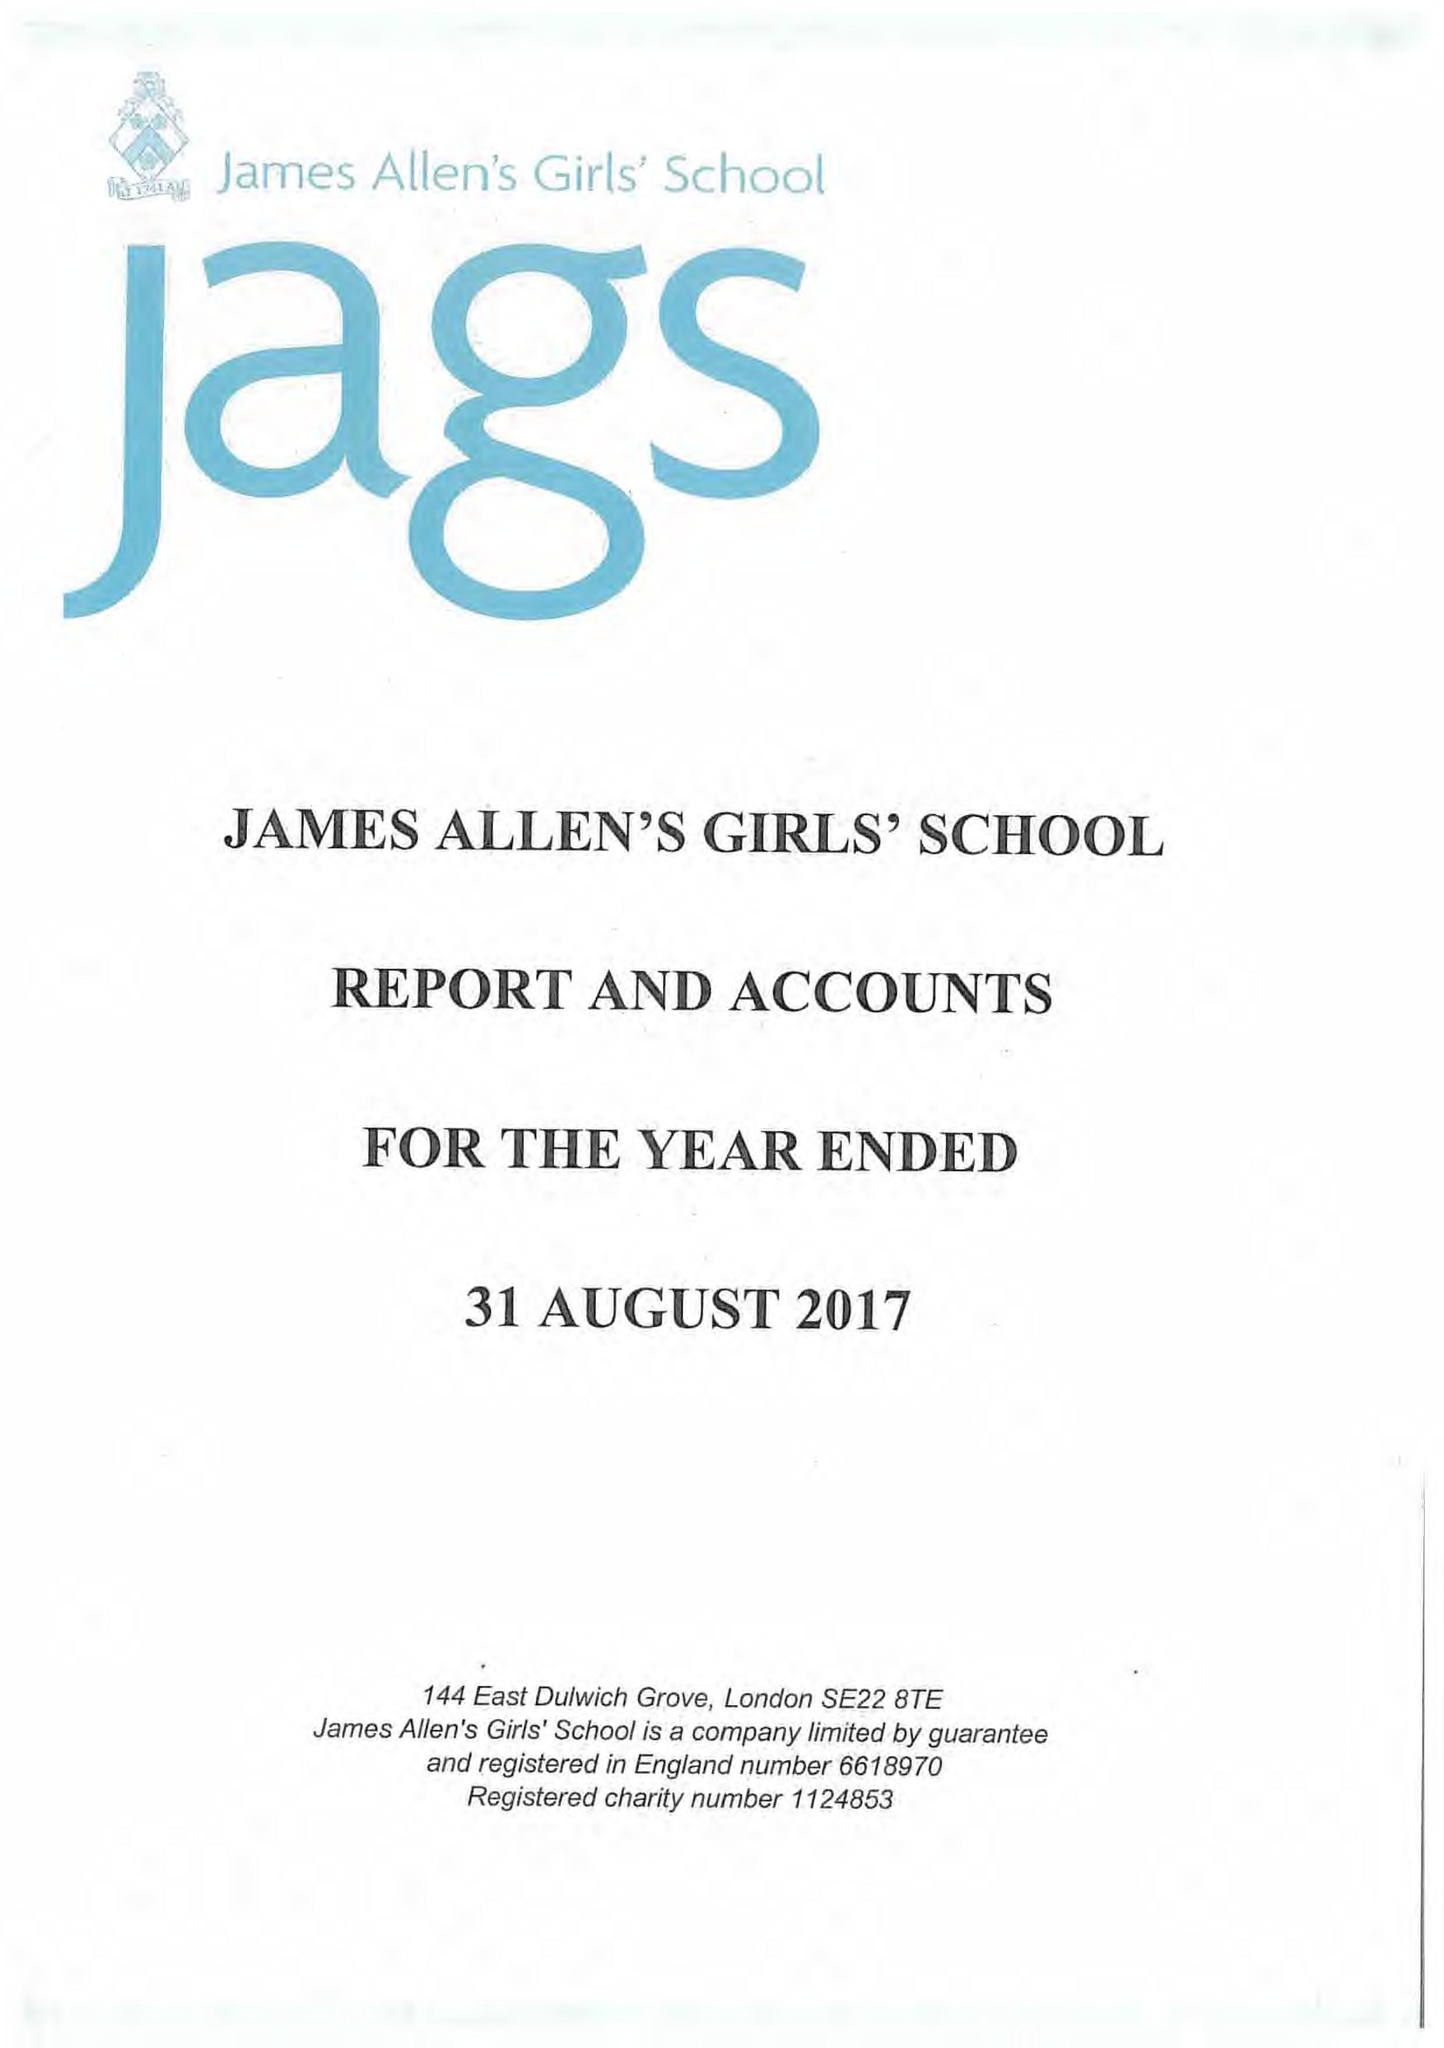What is the value for the income_annually_in_british_pounds?
Answer the question using a single word or phrase. 24429999.00 